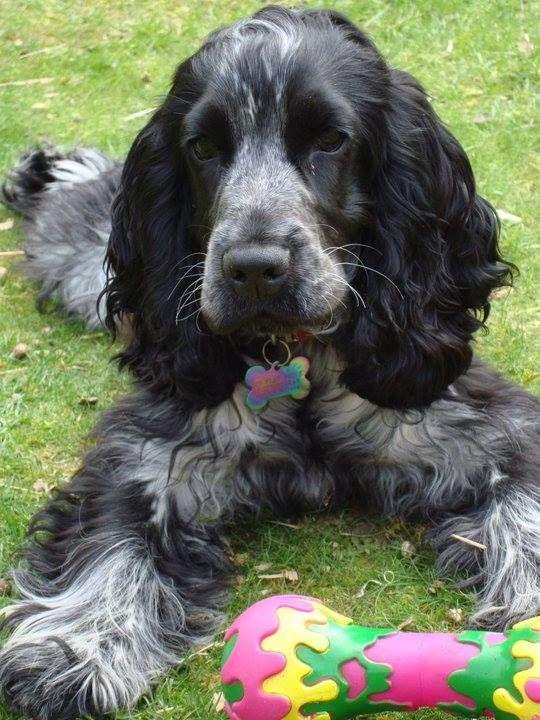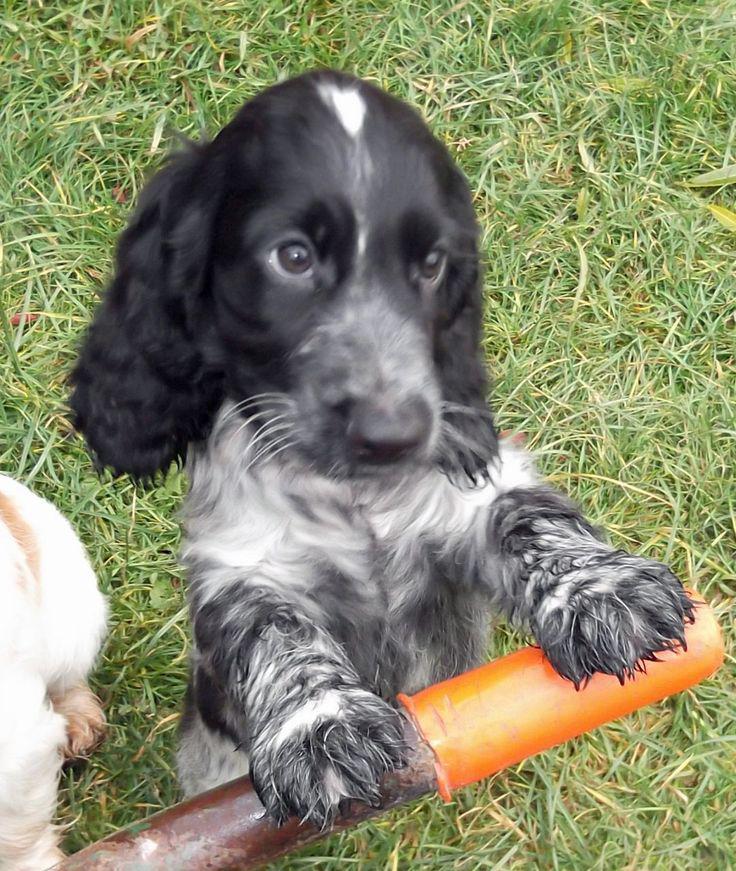The first image is the image on the left, the second image is the image on the right. For the images shown, is this caption "A floppy eared dog is in contact with a stick-like object in one image." true? Answer yes or no. Yes. The first image is the image on the left, the second image is the image on the right. Assess this claim about the two images: "In one image, a small black and gray dog is being held outdoors with its front paws draped over a hand, while a similar dog in a second image is sitting outdoors.". Correct or not? Answer yes or no. No. 